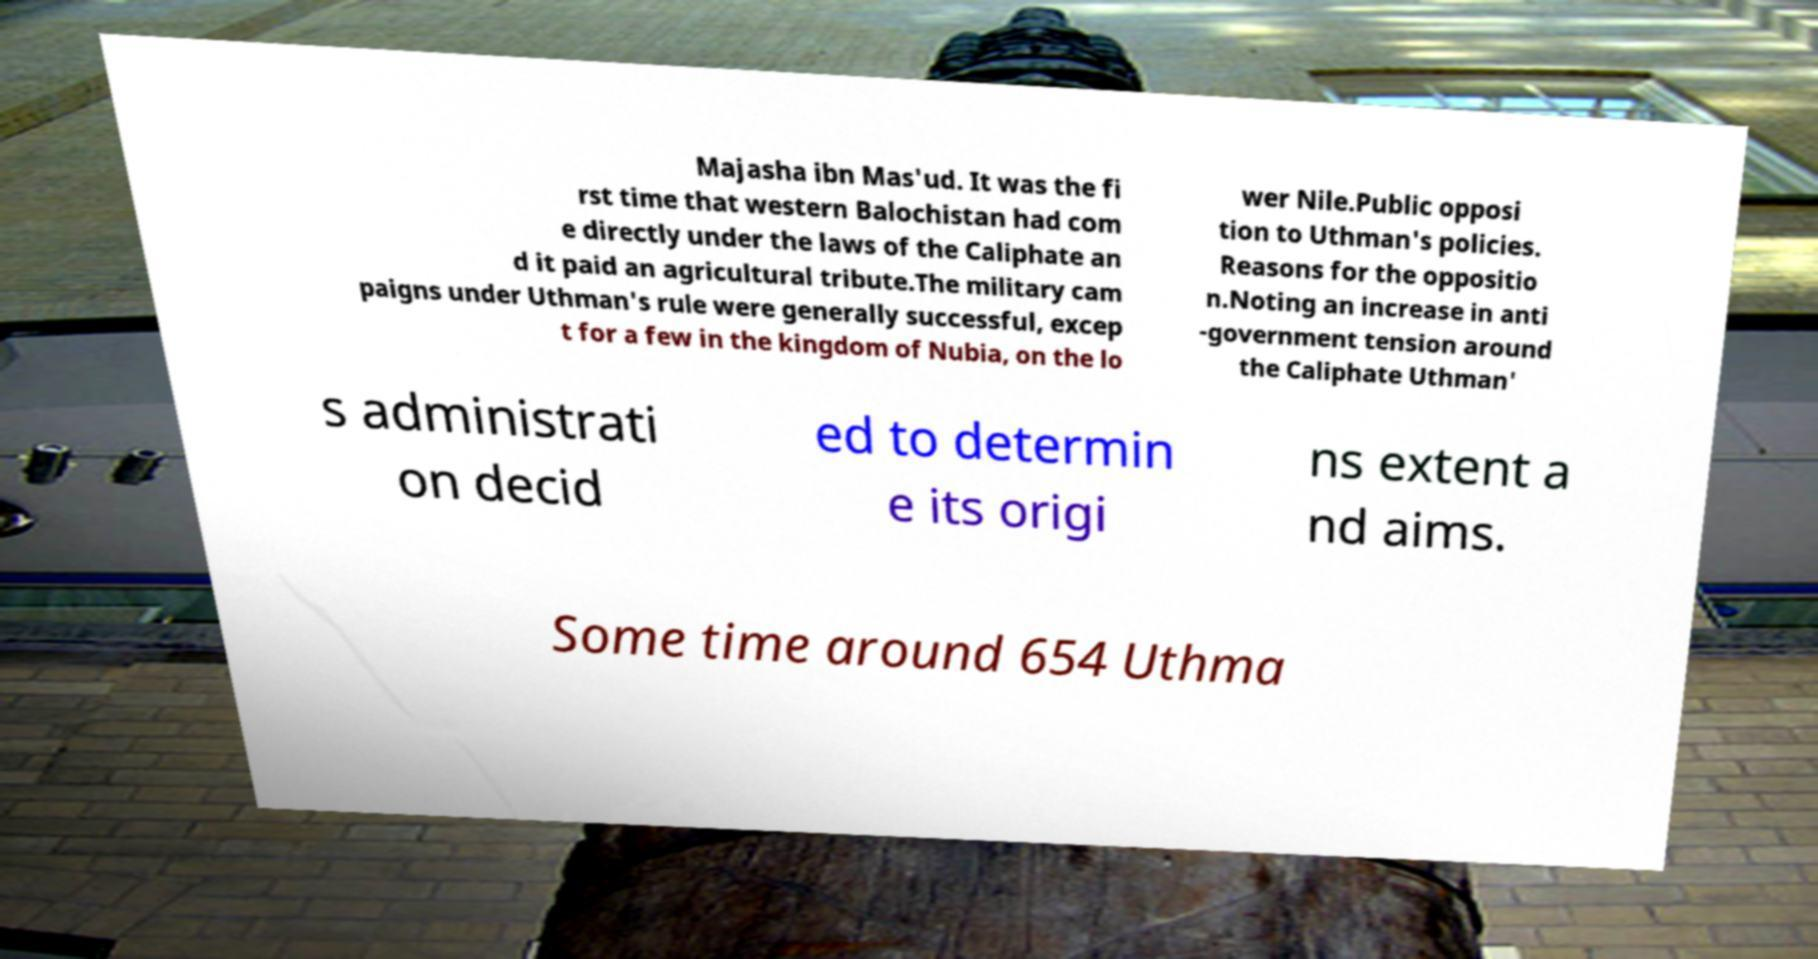Could you assist in decoding the text presented in this image and type it out clearly? Majasha ibn Mas'ud. It was the fi rst time that western Balochistan had com e directly under the laws of the Caliphate an d it paid an agricultural tribute.The military cam paigns under Uthman's rule were generally successful, excep t for a few in the kingdom of Nubia, on the lo wer Nile.Public opposi tion to Uthman's policies. Reasons for the oppositio n.Noting an increase in anti -government tension around the Caliphate Uthman' s administrati on decid ed to determin e its origi ns extent a nd aims. Some time around 654 Uthma 